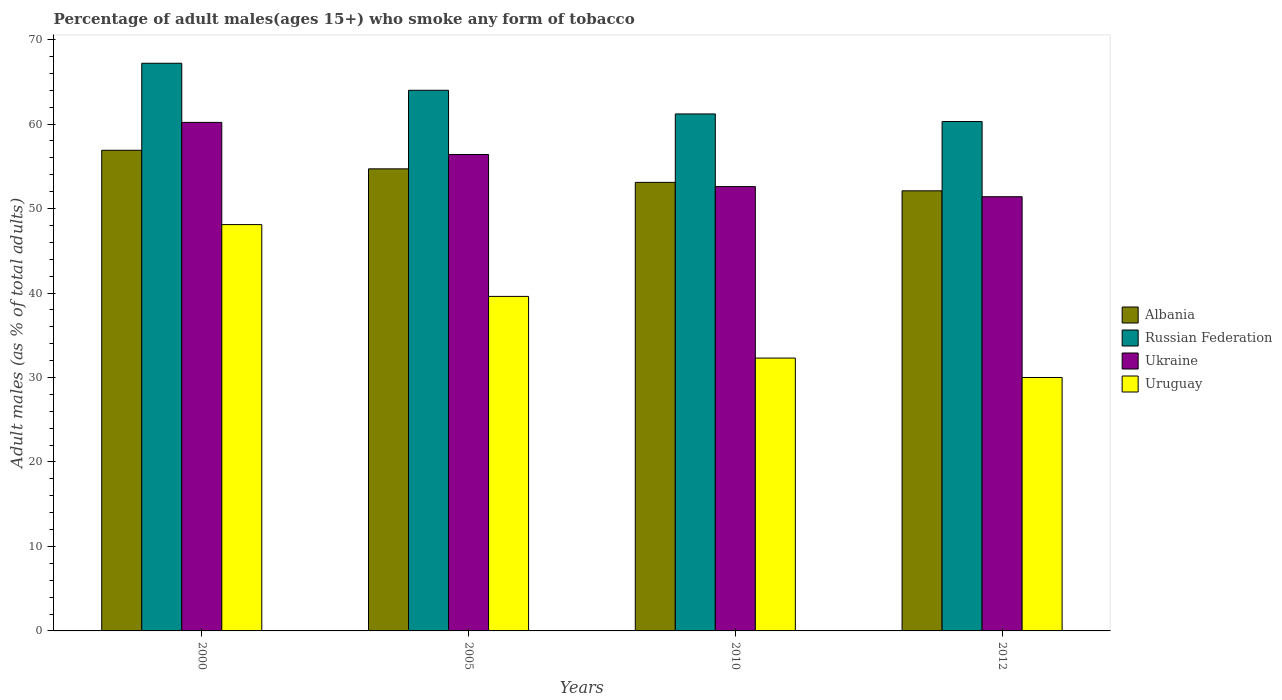How many groups of bars are there?
Your answer should be very brief. 4. Are the number of bars on each tick of the X-axis equal?
Keep it short and to the point. Yes. How many bars are there on the 4th tick from the left?
Your response must be concise. 4. What is the percentage of adult males who smoke in Russian Federation in 2000?
Provide a short and direct response. 67.2. Across all years, what is the maximum percentage of adult males who smoke in Albania?
Provide a short and direct response. 56.9. Across all years, what is the minimum percentage of adult males who smoke in Ukraine?
Your response must be concise. 51.4. In which year was the percentage of adult males who smoke in Russian Federation minimum?
Offer a terse response. 2012. What is the total percentage of adult males who smoke in Russian Federation in the graph?
Offer a terse response. 252.7. What is the difference between the percentage of adult males who smoke in Uruguay in 2000 and that in 2005?
Give a very brief answer. 8.5. What is the average percentage of adult males who smoke in Albania per year?
Provide a succinct answer. 54.2. In the year 2010, what is the difference between the percentage of adult males who smoke in Uruguay and percentage of adult males who smoke in Albania?
Make the answer very short. -20.8. What is the ratio of the percentage of adult males who smoke in Uruguay in 2010 to that in 2012?
Your answer should be very brief. 1.08. Is the percentage of adult males who smoke in Russian Federation in 2010 less than that in 2012?
Offer a terse response. No. What is the difference between the highest and the second highest percentage of adult males who smoke in Albania?
Offer a terse response. 2.2. What is the difference between the highest and the lowest percentage of adult males who smoke in Albania?
Offer a terse response. 4.8. Is the sum of the percentage of adult males who smoke in Ukraine in 2005 and 2010 greater than the maximum percentage of adult males who smoke in Uruguay across all years?
Make the answer very short. Yes. Is it the case that in every year, the sum of the percentage of adult males who smoke in Russian Federation and percentage of adult males who smoke in Uruguay is greater than the sum of percentage of adult males who smoke in Ukraine and percentage of adult males who smoke in Albania?
Your answer should be compact. No. What does the 2nd bar from the left in 2005 represents?
Offer a very short reply. Russian Federation. What does the 3rd bar from the right in 2012 represents?
Offer a very short reply. Russian Federation. Is it the case that in every year, the sum of the percentage of adult males who smoke in Ukraine and percentage of adult males who smoke in Russian Federation is greater than the percentage of adult males who smoke in Uruguay?
Ensure brevity in your answer.  Yes. How many bars are there?
Make the answer very short. 16. What is the difference between two consecutive major ticks on the Y-axis?
Offer a very short reply. 10. Does the graph contain grids?
Your answer should be compact. No. How many legend labels are there?
Provide a succinct answer. 4. How are the legend labels stacked?
Give a very brief answer. Vertical. What is the title of the graph?
Ensure brevity in your answer.  Percentage of adult males(ages 15+) who smoke any form of tobacco. Does "Germany" appear as one of the legend labels in the graph?
Ensure brevity in your answer.  No. What is the label or title of the X-axis?
Offer a terse response. Years. What is the label or title of the Y-axis?
Provide a short and direct response. Adult males (as % of total adults). What is the Adult males (as % of total adults) in Albania in 2000?
Provide a short and direct response. 56.9. What is the Adult males (as % of total adults) of Russian Federation in 2000?
Provide a succinct answer. 67.2. What is the Adult males (as % of total adults) of Ukraine in 2000?
Your response must be concise. 60.2. What is the Adult males (as % of total adults) of Uruguay in 2000?
Offer a very short reply. 48.1. What is the Adult males (as % of total adults) of Albania in 2005?
Offer a terse response. 54.7. What is the Adult males (as % of total adults) of Russian Federation in 2005?
Offer a very short reply. 64. What is the Adult males (as % of total adults) of Ukraine in 2005?
Keep it short and to the point. 56.4. What is the Adult males (as % of total adults) of Uruguay in 2005?
Make the answer very short. 39.6. What is the Adult males (as % of total adults) of Albania in 2010?
Offer a terse response. 53.1. What is the Adult males (as % of total adults) of Russian Federation in 2010?
Provide a short and direct response. 61.2. What is the Adult males (as % of total adults) of Ukraine in 2010?
Give a very brief answer. 52.6. What is the Adult males (as % of total adults) in Uruguay in 2010?
Your answer should be compact. 32.3. What is the Adult males (as % of total adults) in Albania in 2012?
Offer a terse response. 52.1. What is the Adult males (as % of total adults) in Russian Federation in 2012?
Provide a succinct answer. 60.3. What is the Adult males (as % of total adults) of Ukraine in 2012?
Ensure brevity in your answer.  51.4. Across all years, what is the maximum Adult males (as % of total adults) in Albania?
Your answer should be compact. 56.9. Across all years, what is the maximum Adult males (as % of total adults) of Russian Federation?
Make the answer very short. 67.2. Across all years, what is the maximum Adult males (as % of total adults) in Ukraine?
Offer a very short reply. 60.2. Across all years, what is the maximum Adult males (as % of total adults) of Uruguay?
Keep it short and to the point. 48.1. Across all years, what is the minimum Adult males (as % of total adults) of Albania?
Your response must be concise. 52.1. Across all years, what is the minimum Adult males (as % of total adults) in Russian Federation?
Your answer should be very brief. 60.3. Across all years, what is the minimum Adult males (as % of total adults) of Ukraine?
Your response must be concise. 51.4. What is the total Adult males (as % of total adults) in Albania in the graph?
Provide a short and direct response. 216.8. What is the total Adult males (as % of total adults) of Russian Federation in the graph?
Ensure brevity in your answer.  252.7. What is the total Adult males (as % of total adults) in Ukraine in the graph?
Your response must be concise. 220.6. What is the total Adult males (as % of total adults) of Uruguay in the graph?
Your answer should be compact. 150. What is the difference between the Adult males (as % of total adults) of Russian Federation in 2000 and that in 2005?
Offer a terse response. 3.2. What is the difference between the Adult males (as % of total adults) in Russian Federation in 2000 and that in 2010?
Provide a succinct answer. 6. What is the difference between the Adult males (as % of total adults) of Ukraine in 2000 and that in 2010?
Ensure brevity in your answer.  7.6. What is the difference between the Adult males (as % of total adults) in Uruguay in 2000 and that in 2010?
Offer a terse response. 15.8. What is the difference between the Adult males (as % of total adults) in Uruguay in 2000 and that in 2012?
Your answer should be very brief. 18.1. What is the difference between the Adult males (as % of total adults) of Albania in 2005 and that in 2012?
Provide a succinct answer. 2.6. What is the difference between the Adult males (as % of total adults) of Ukraine in 2005 and that in 2012?
Your answer should be compact. 5. What is the difference between the Adult males (as % of total adults) in Ukraine in 2010 and that in 2012?
Provide a short and direct response. 1.2. What is the difference between the Adult males (as % of total adults) in Uruguay in 2010 and that in 2012?
Offer a terse response. 2.3. What is the difference between the Adult males (as % of total adults) of Albania in 2000 and the Adult males (as % of total adults) of Russian Federation in 2005?
Your answer should be compact. -7.1. What is the difference between the Adult males (as % of total adults) of Albania in 2000 and the Adult males (as % of total adults) of Ukraine in 2005?
Provide a short and direct response. 0.5. What is the difference between the Adult males (as % of total adults) in Russian Federation in 2000 and the Adult males (as % of total adults) in Ukraine in 2005?
Provide a short and direct response. 10.8. What is the difference between the Adult males (as % of total adults) of Russian Federation in 2000 and the Adult males (as % of total adults) of Uruguay in 2005?
Your answer should be compact. 27.6. What is the difference between the Adult males (as % of total adults) in Ukraine in 2000 and the Adult males (as % of total adults) in Uruguay in 2005?
Offer a terse response. 20.6. What is the difference between the Adult males (as % of total adults) of Albania in 2000 and the Adult males (as % of total adults) of Uruguay in 2010?
Your answer should be very brief. 24.6. What is the difference between the Adult males (as % of total adults) in Russian Federation in 2000 and the Adult males (as % of total adults) in Uruguay in 2010?
Ensure brevity in your answer.  34.9. What is the difference between the Adult males (as % of total adults) of Ukraine in 2000 and the Adult males (as % of total adults) of Uruguay in 2010?
Offer a terse response. 27.9. What is the difference between the Adult males (as % of total adults) in Albania in 2000 and the Adult males (as % of total adults) in Russian Federation in 2012?
Make the answer very short. -3.4. What is the difference between the Adult males (as % of total adults) of Albania in 2000 and the Adult males (as % of total adults) of Ukraine in 2012?
Give a very brief answer. 5.5. What is the difference between the Adult males (as % of total adults) of Albania in 2000 and the Adult males (as % of total adults) of Uruguay in 2012?
Provide a short and direct response. 26.9. What is the difference between the Adult males (as % of total adults) in Russian Federation in 2000 and the Adult males (as % of total adults) in Uruguay in 2012?
Provide a short and direct response. 37.2. What is the difference between the Adult males (as % of total adults) in Ukraine in 2000 and the Adult males (as % of total adults) in Uruguay in 2012?
Give a very brief answer. 30.2. What is the difference between the Adult males (as % of total adults) of Albania in 2005 and the Adult males (as % of total adults) of Russian Federation in 2010?
Offer a terse response. -6.5. What is the difference between the Adult males (as % of total adults) of Albania in 2005 and the Adult males (as % of total adults) of Ukraine in 2010?
Your answer should be compact. 2.1. What is the difference between the Adult males (as % of total adults) in Albania in 2005 and the Adult males (as % of total adults) in Uruguay in 2010?
Provide a short and direct response. 22.4. What is the difference between the Adult males (as % of total adults) in Russian Federation in 2005 and the Adult males (as % of total adults) in Uruguay in 2010?
Your response must be concise. 31.7. What is the difference between the Adult males (as % of total adults) of Ukraine in 2005 and the Adult males (as % of total adults) of Uruguay in 2010?
Keep it short and to the point. 24.1. What is the difference between the Adult males (as % of total adults) in Albania in 2005 and the Adult males (as % of total adults) in Uruguay in 2012?
Your response must be concise. 24.7. What is the difference between the Adult males (as % of total adults) in Ukraine in 2005 and the Adult males (as % of total adults) in Uruguay in 2012?
Provide a succinct answer. 26.4. What is the difference between the Adult males (as % of total adults) of Albania in 2010 and the Adult males (as % of total adults) of Russian Federation in 2012?
Your answer should be compact. -7.2. What is the difference between the Adult males (as % of total adults) of Albania in 2010 and the Adult males (as % of total adults) of Uruguay in 2012?
Offer a very short reply. 23.1. What is the difference between the Adult males (as % of total adults) of Russian Federation in 2010 and the Adult males (as % of total adults) of Ukraine in 2012?
Make the answer very short. 9.8. What is the difference between the Adult males (as % of total adults) in Russian Federation in 2010 and the Adult males (as % of total adults) in Uruguay in 2012?
Your answer should be compact. 31.2. What is the difference between the Adult males (as % of total adults) of Ukraine in 2010 and the Adult males (as % of total adults) of Uruguay in 2012?
Keep it short and to the point. 22.6. What is the average Adult males (as % of total adults) in Albania per year?
Make the answer very short. 54.2. What is the average Adult males (as % of total adults) in Russian Federation per year?
Offer a very short reply. 63.17. What is the average Adult males (as % of total adults) of Ukraine per year?
Ensure brevity in your answer.  55.15. What is the average Adult males (as % of total adults) of Uruguay per year?
Provide a succinct answer. 37.5. In the year 2000, what is the difference between the Adult males (as % of total adults) of Albania and Adult males (as % of total adults) of Russian Federation?
Make the answer very short. -10.3. In the year 2000, what is the difference between the Adult males (as % of total adults) in Russian Federation and Adult males (as % of total adults) in Uruguay?
Make the answer very short. 19.1. In the year 2005, what is the difference between the Adult males (as % of total adults) in Albania and Adult males (as % of total adults) in Russian Federation?
Provide a short and direct response. -9.3. In the year 2005, what is the difference between the Adult males (as % of total adults) of Russian Federation and Adult males (as % of total adults) of Ukraine?
Your response must be concise. 7.6. In the year 2005, what is the difference between the Adult males (as % of total adults) of Russian Federation and Adult males (as % of total adults) of Uruguay?
Provide a short and direct response. 24.4. In the year 2005, what is the difference between the Adult males (as % of total adults) of Ukraine and Adult males (as % of total adults) of Uruguay?
Give a very brief answer. 16.8. In the year 2010, what is the difference between the Adult males (as % of total adults) in Albania and Adult males (as % of total adults) in Russian Federation?
Your response must be concise. -8.1. In the year 2010, what is the difference between the Adult males (as % of total adults) of Albania and Adult males (as % of total adults) of Ukraine?
Provide a short and direct response. 0.5. In the year 2010, what is the difference between the Adult males (as % of total adults) of Albania and Adult males (as % of total adults) of Uruguay?
Keep it short and to the point. 20.8. In the year 2010, what is the difference between the Adult males (as % of total adults) in Russian Federation and Adult males (as % of total adults) in Ukraine?
Your answer should be compact. 8.6. In the year 2010, what is the difference between the Adult males (as % of total adults) of Russian Federation and Adult males (as % of total adults) of Uruguay?
Give a very brief answer. 28.9. In the year 2010, what is the difference between the Adult males (as % of total adults) in Ukraine and Adult males (as % of total adults) in Uruguay?
Your response must be concise. 20.3. In the year 2012, what is the difference between the Adult males (as % of total adults) in Albania and Adult males (as % of total adults) in Russian Federation?
Provide a short and direct response. -8.2. In the year 2012, what is the difference between the Adult males (as % of total adults) of Albania and Adult males (as % of total adults) of Ukraine?
Make the answer very short. 0.7. In the year 2012, what is the difference between the Adult males (as % of total adults) of Albania and Adult males (as % of total adults) of Uruguay?
Offer a very short reply. 22.1. In the year 2012, what is the difference between the Adult males (as % of total adults) in Russian Federation and Adult males (as % of total adults) in Ukraine?
Your answer should be compact. 8.9. In the year 2012, what is the difference between the Adult males (as % of total adults) in Russian Federation and Adult males (as % of total adults) in Uruguay?
Offer a very short reply. 30.3. In the year 2012, what is the difference between the Adult males (as % of total adults) of Ukraine and Adult males (as % of total adults) of Uruguay?
Make the answer very short. 21.4. What is the ratio of the Adult males (as % of total adults) in Albania in 2000 to that in 2005?
Your response must be concise. 1.04. What is the ratio of the Adult males (as % of total adults) of Ukraine in 2000 to that in 2005?
Offer a very short reply. 1.07. What is the ratio of the Adult males (as % of total adults) in Uruguay in 2000 to that in 2005?
Offer a very short reply. 1.21. What is the ratio of the Adult males (as % of total adults) of Albania in 2000 to that in 2010?
Your answer should be compact. 1.07. What is the ratio of the Adult males (as % of total adults) in Russian Federation in 2000 to that in 2010?
Give a very brief answer. 1.1. What is the ratio of the Adult males (as % of total adults) of Ukraine in 2000 to that in 2010?
Offer a very short reply. 1.14. What is the ratio of the Adult males (as % of total adults) of Uruguay in 2000 to that in 2010?
Offer a very short reply. 1.49. What is the ratio of the Adult males (as % of total adults) in Albania in 2000 to that in 2012?
Your answer should be very brief. 1.09. What is the ratio of the Adult males (as % of total adults) in Russian Federation in 2000 to that in 2012?
Provide a succinct answer. 1.11. What is the ratio of the Adult males (as % of total adults) of Ukraine in 2000 to that in 2012?
Make the answer very short. 1.17. What is the ratio of the Adult males (as % of total adults) of Uruguay in 2000 to that in 2012?
Provide a short and direct response. 1.6. What is the ratio of the Adult males (as % of total adults) in Albania in 2005 to that in 2010?
Give a very brief answer. 1.03. What is the ratio of the Adult males (as % of total adults) of Russian Federation in 2005 to that in 2010?
Your answer should be very brief. 1.05. What is the ratio of the Adult males (as % of total adults) of Ukraine in 2005 to that in 2010?
Provide a succinct answer. 1.07. What is the ratio of the Adult males (as % of total adults) of Uruguay in 2005 to that in 2010?
Make the answer very short. 1.23. What is the ratio of the Adult males (as % of total adults) of Albania in 2005 to that in 2012?
Your answer should be very brief. 1.05. What is the ratio of the Adult males (as % of total adults) of Russian Federation in 2005 to that in 2012?
Ensure brevity in your answer.  1.06. What is the ratio of the Adult males (as % of total adults) in Ukraine in 2005 to that in 2012?
Offer a terse response. 1.1. What is the ratio of the Adult males (as % of total adults) in Uruguay in 2005 to that in 2012?
Your response must be concise. 1.32. What is the ratio of the Adult males (as % of total adults) of Albania in 2010 to that in 2012?
Keep it short and to the point. 1.02. What is the ratio of the Adult males (as % of total adults) of Russian Federation in 2010 to that in 2012?
Give a very brief answer. 1.01. What is the ratio of the Adult males (as % of total adults) in Ukraine in 2010 to that in 2012?
Give a very brief answer. 1.02. What is the ratio of the Adult males (as % of total adults) in Uruguay in 2010 to that in 2012?
Keep it short and to the point. 1.08. What is the difference between the highest and the second highest Adult males (as % of total adults) in Albania?
Your answer should be very brief. 2.2. What is the difference between the highest and the second highest Adult males (as % of total adults) in Russian Federation?
Give a very brief answer. 3.2. What is the difference between the highest and the second highest Adult males (as % of total adults) in Uruguay?
Keep it short and to the point. 8.5. What is the difference between the highest and the lowest Adult males (as % of total adults) of Russian Federation?
Your answer should be compact. 6.9. What is the difference between the highest and the lowest Adult males (as % of total adults) in Uruguay?
Offer a very short reply. 18.1. 